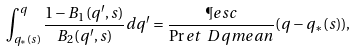Convert formula to latex. <formula><loc_0><loc_0><loc_500><loc_500>\int _ { q _ { * } ( s ) } ^ { q } \frac { 1 - B _ { 1 } ( q ^ { \prime } , s ) } { B _ { 2 } ( q ^ { \prime } , s ) } d q ^ { \prime } = \frac { \P e s c } { \Pr e t \ D q m e a n } ( q - q _ { * } ( s ) ) ,</formula> 